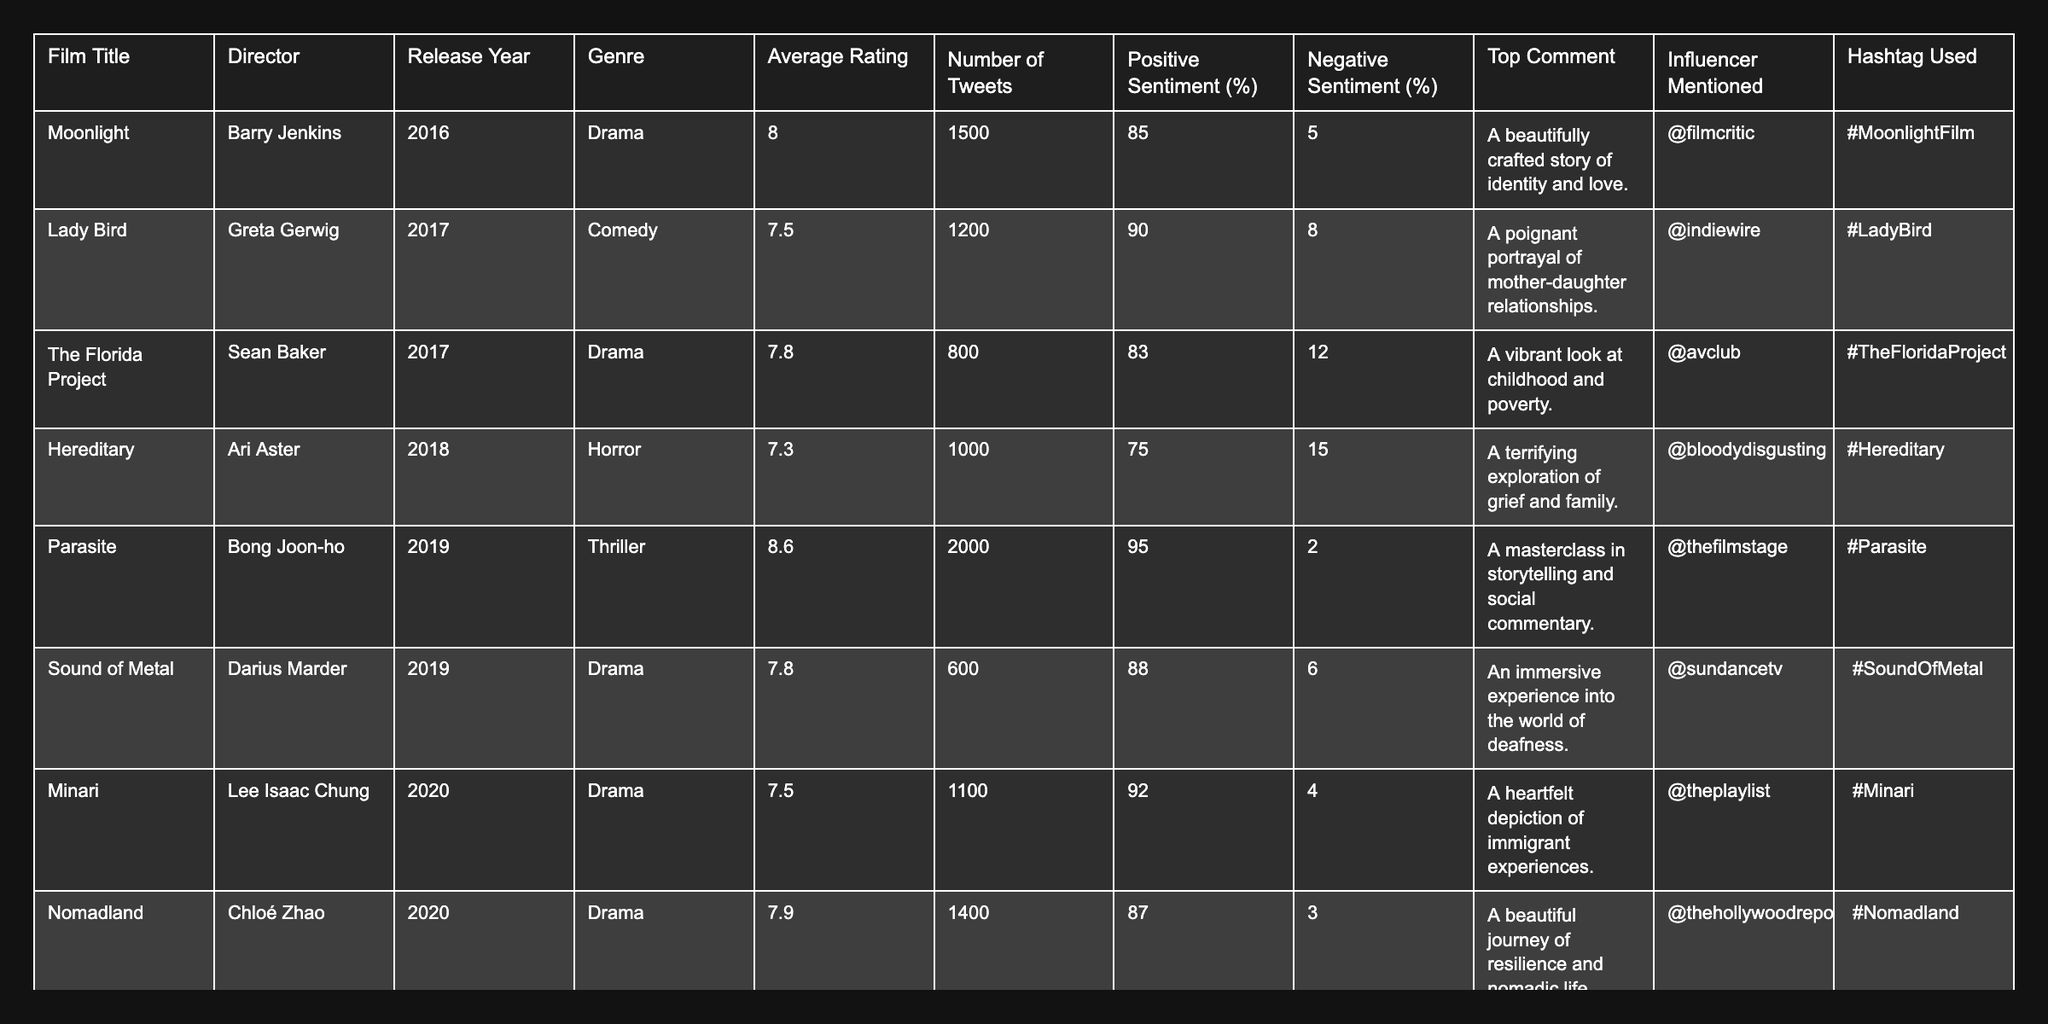What is the film with the highest average rating? The table shows the average ratings for each film. "Parasite" has the highest average rating at 8.6.
Answer: Parasite How many tweets were made about "Lady Bird"? The number of tweets for "Lady Bird" is directly listed in the table, which shows 1200 tweets.
Answer: 1200 Which film has the lowest percentage of positive sentiment? By looking through the percentages of positive sentiment in the table, "Hereditary" has the lowest value at 75%.
Answer: 75% What percentage of tweets for "The Florida Project" are negative? The table indicates that "The Florida Project" has a negative sentiment percentage of 12%.
Answer: 12% What is the average rating of films from the drama genre? The average ratings of drama films can be found in the table: "Moonlight" (8.0), "The Florida Project" (7.8), "Sound of Metal" (7.8), "Minari" (7.5), "Nomadland" (7.9). The average is (8.0 + 7.8 + 7.8 + 7.5 + 7.9) / 5 = 7.84.
Answer: 7.84 Which director received the most mentions from influencers in the comments? The table shows each film and its associated influencer mention. "Parasite" directed by Bong Joon-ho is mentioned once by "@thefilmstage", while all others are also mentioned once or not at all. No director stands out as having more mentions than others.
Answer: No director received more mentions Is the average rating of "Promising Young Woman" higher than that of "Hereditary"? "Promising Young Woman" has an average rating of 7.5 and "Hereditary" has 7.3. Comparing these values shows that 7.5 is higher than 7.3.
Answer: Yes What is the total number of tweets for all films listed? To find the total, add the number of tweets for each film: 1500 + 1200 + 800 + 1000 + 2000 + 600 + 1100 + 1400 + 900 = 10300.
Answer: 10300 How many films have a positive sentiment percentage above 85%? The percentage of positive sentiment above 85% can be found for the films: "Moonlight" (85%), "Lady Bird" (90%), "Parasite" (95%), "Sound of Metal" (88%), "Minari" (92%). The count of films meeting this criterion is 5.
Answer: 5 Which film genre has the highest occurrence in the given data? By reviewing the genres listed in the table, there are five drama films and two thrillers, one horror, and one comedy. Drama is the most common genre.
Answer: Drama 